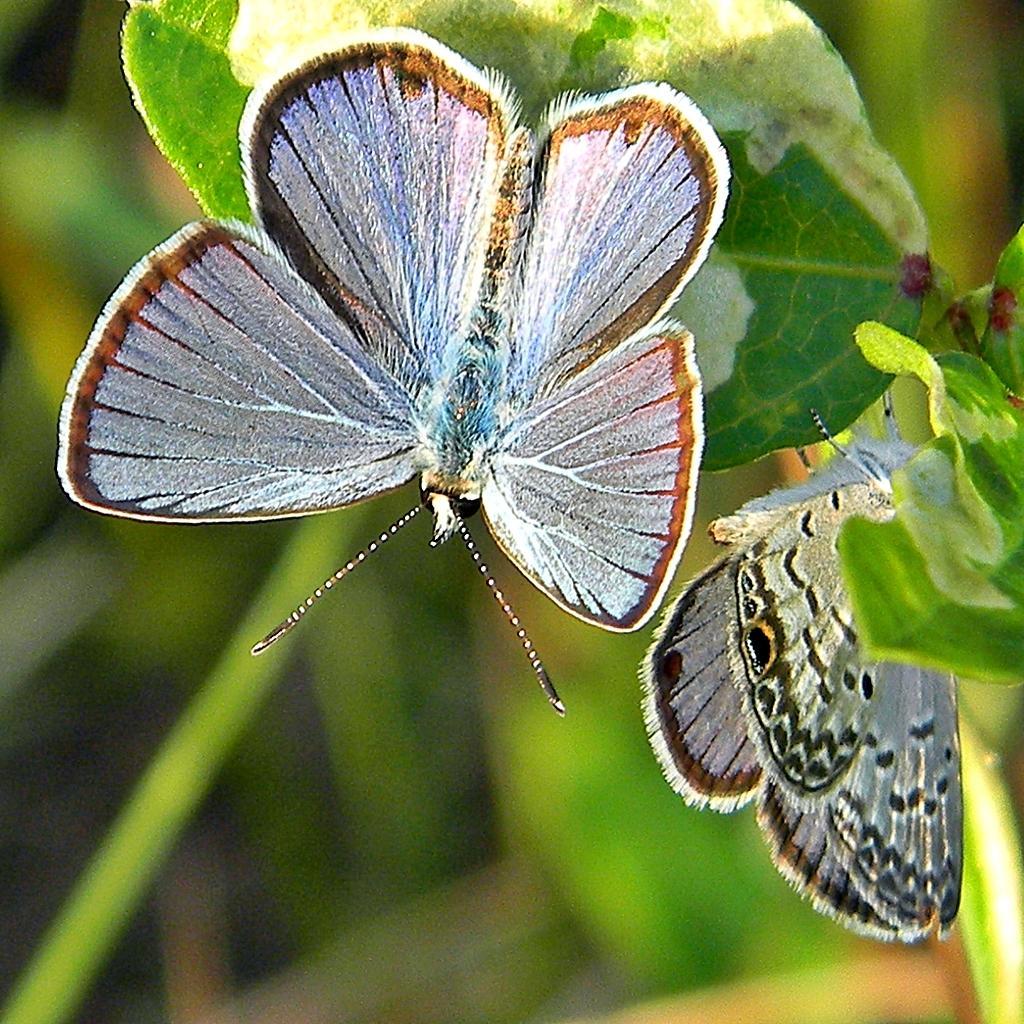Describe this image in one or two sentences. In this image I can see few butterflies. They are in white and brown color. Butterfly are on the leaves. Background is in green color. 